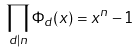<formula> <loc_0><loc_0><loc_500><loc_500>\prod _ { d | n } \Phi _ { d } ( x ) = x ^ { n } - 1</formula> 